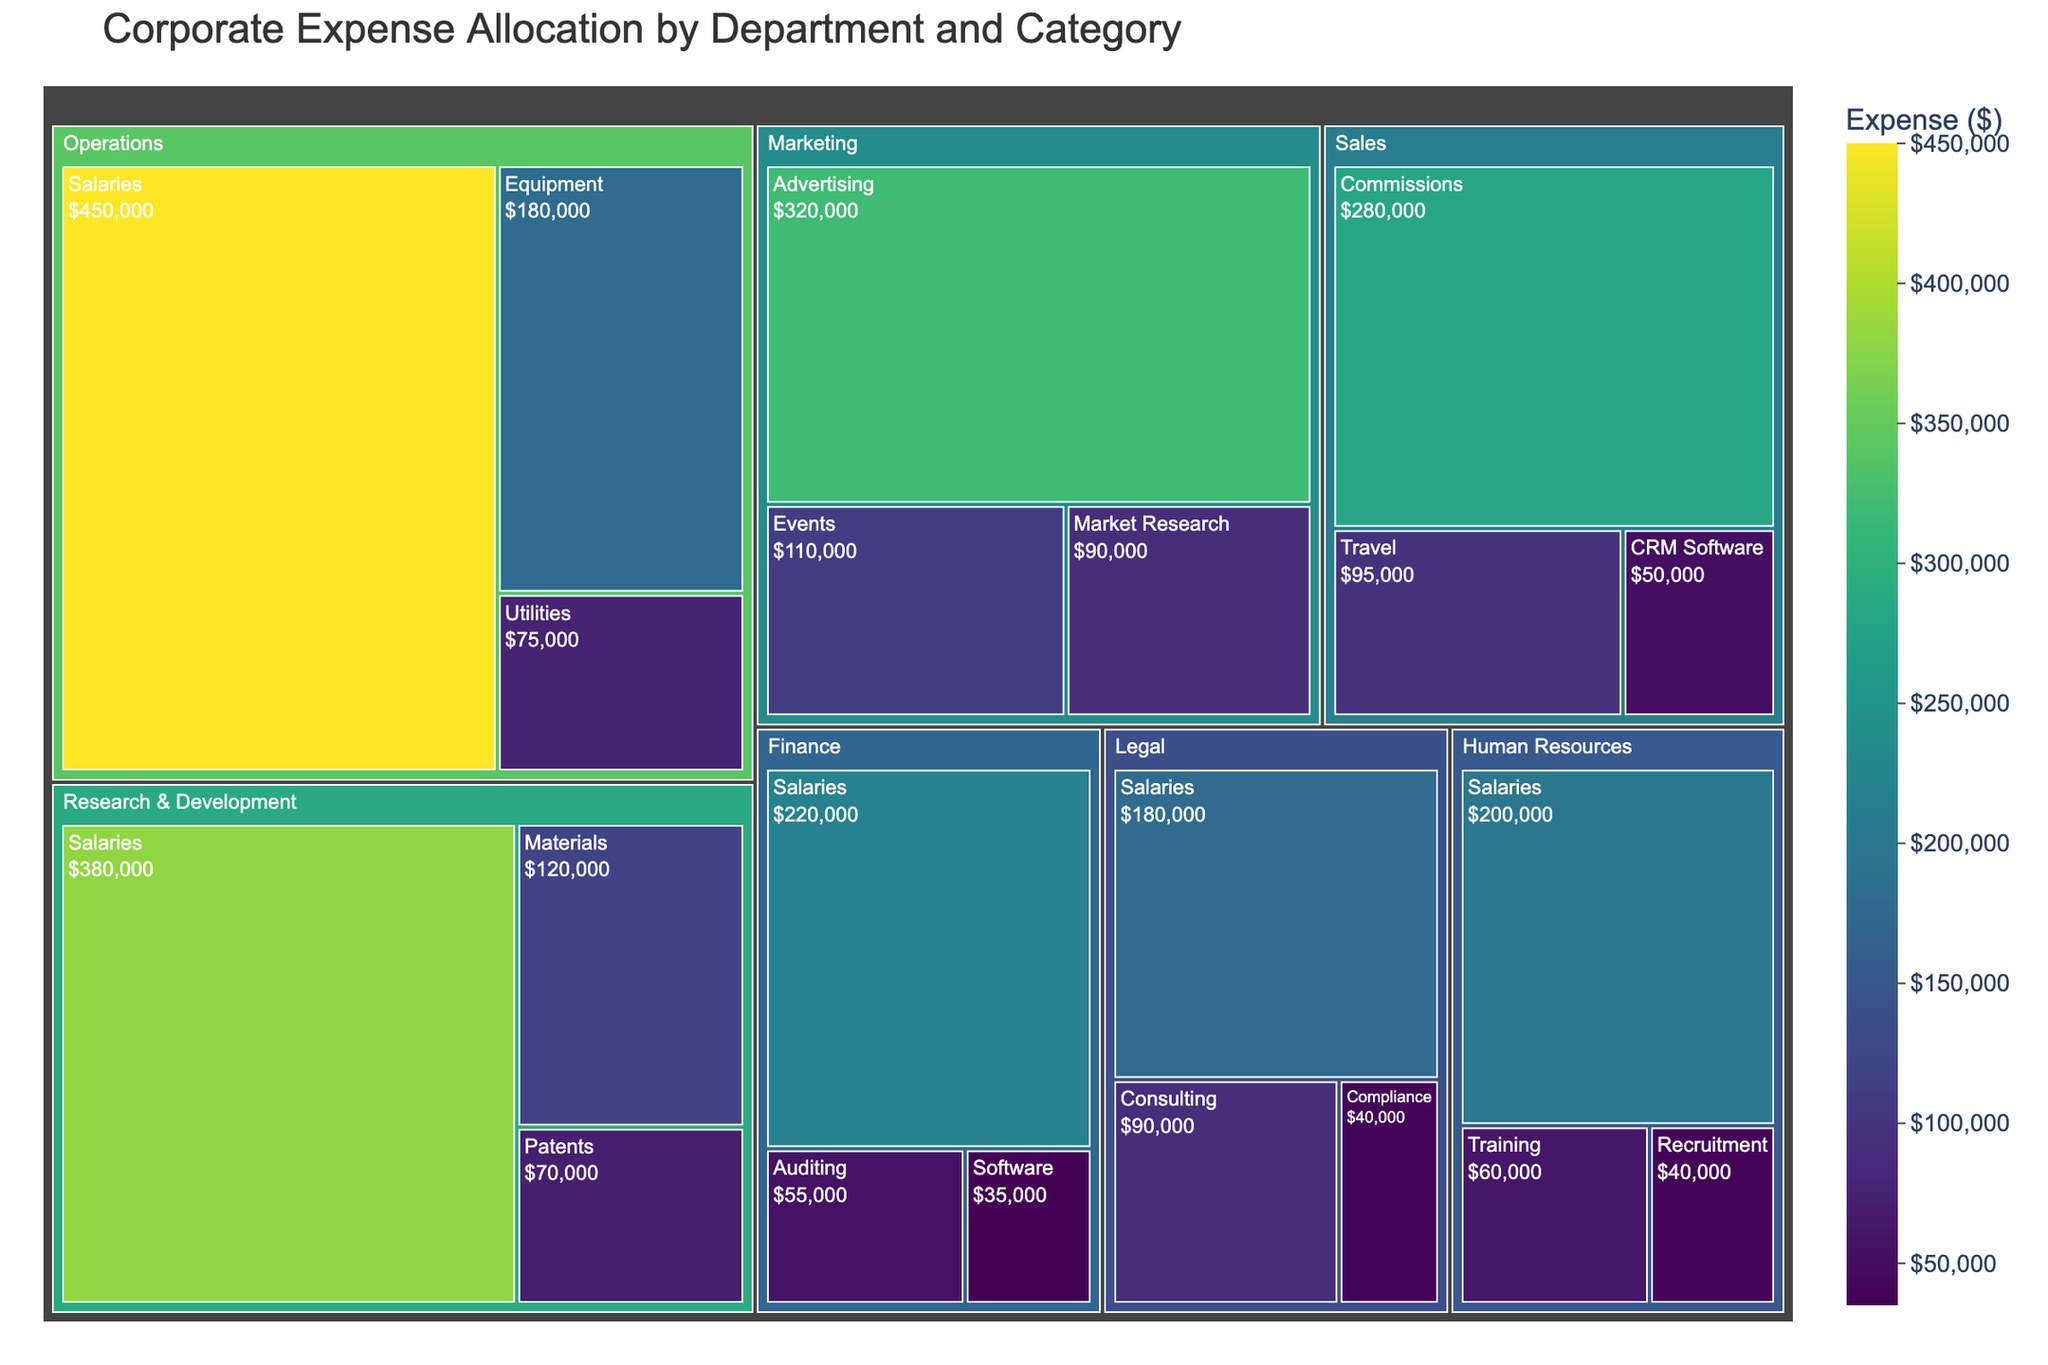What's the largest spending category for the Marketing department? Look for the Marketing department in the treemap and check the size of the different spending categories. Advertising has the largest block within Marketing.
Answer: Advertising Which department has the highest total expense? Identify the department with the largest area in the treemap. Operations has the largest area, indicating it has the highest total expense.
Answer: Operations How much is spent on Salaries across all departments? Sum up the expenses for the Salaries category in all departments: Operations ($450,000), R&D ($380,000), HR ($200,000), Finance ($220,000), and Legal ($180,000). Total = $450,000 + $380,000 + $200,000 + $220,000 + $180,000.
Answer: $1,430,000 Which category has the smallest expense in the Finance department? In the Finance department section, look for the smallest block. The Software category has the smallest block.
Answer: Software Compare the total expenses between Sales and Legal departments. Which one is larger and by how much? Sum the expenses for Sales: $280,000 (Commissions) + $95,000 (Travel) + $50,000 (CRM Software) = $425,000. For Legal: $180,000 (Salaries) + $90,000 (Consulting) + $40,000 (Compliance) = $310,000. Sales has a higher expense by $425,000 - $310,000.
Answer: Sales, by $115,000 What's the most common expense category across all departments? Count how many departments include each category. Salaries appear in Operations, R&D, HR, Finance, and Legal, making it the most frequent.
Answer: Salaries How much is spent on consulting services in the company? The Consulting expense appears only under Legal with an expense of $90,000.
Answer: $90,000 What is the difference in equipment expenses between Operations and Research & Development? Find the equipment expenses in Operations ($180,000) and compare it to R&D's Materials expense ($120,000). Difference = $180,000 - $120,000.
Answer: $60,000 Which category in Human Resources has the smallest expense? Examine the blocks within Human Resources and identify the smallest one. Recruitment has the smallest expense.
Answer: Recruitment How does the expense on CRM Software for Sales compare to the expense on Software for Finance? Check the expenses: Sales (CRM Software) is $50,000 and Finance (Software) is $35,000. Sales' CRM Software expense is higher.
Answer: Sales' CRM Software is higher by $15,000 